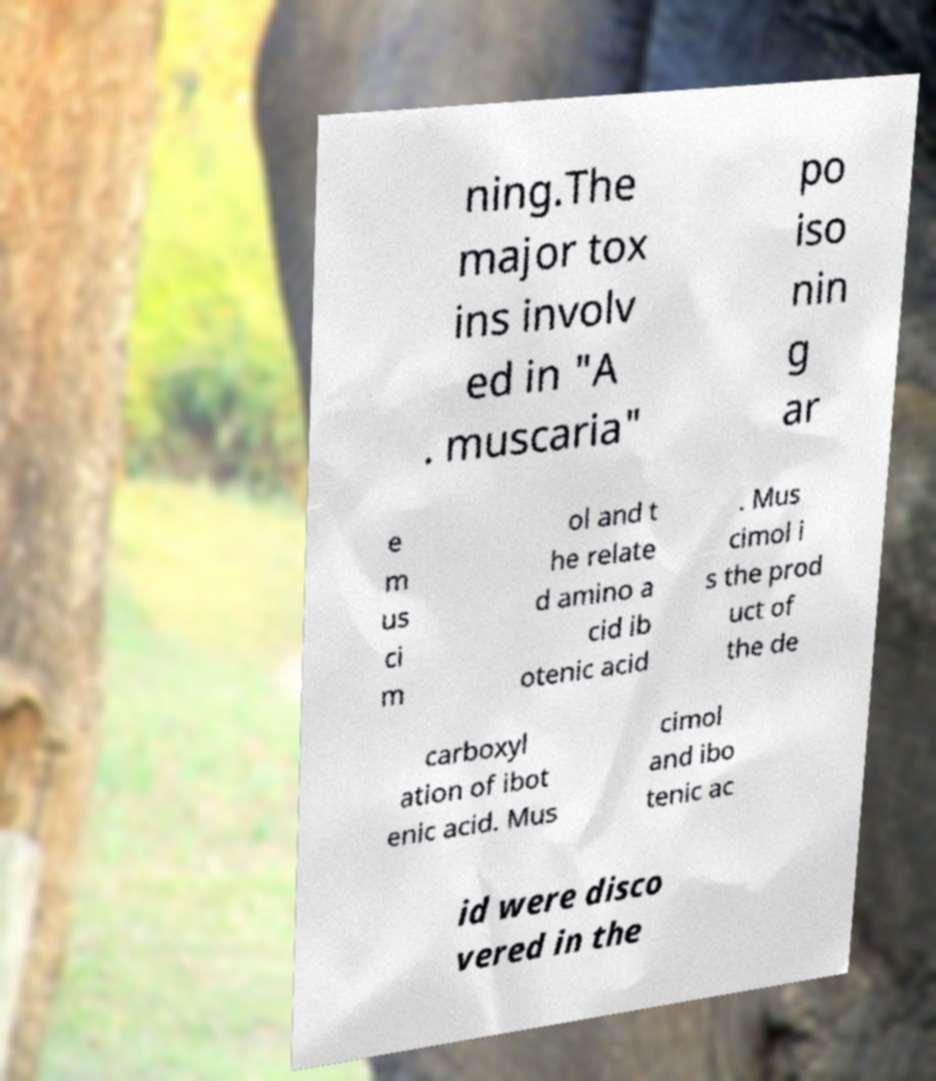Could you assist in decoding the text presented in this image and type it out clearly? ning.The major tox ins involv ed in "A . muscaria" po iso nin g ar e m us ci m ol and t he relate d amino a cid ib otenic acid . Mus cimol i s the prod uct of the de carboxyl ation of ibot enic acid. Mus cimol and ibo tenic ac id were disco vered in the 